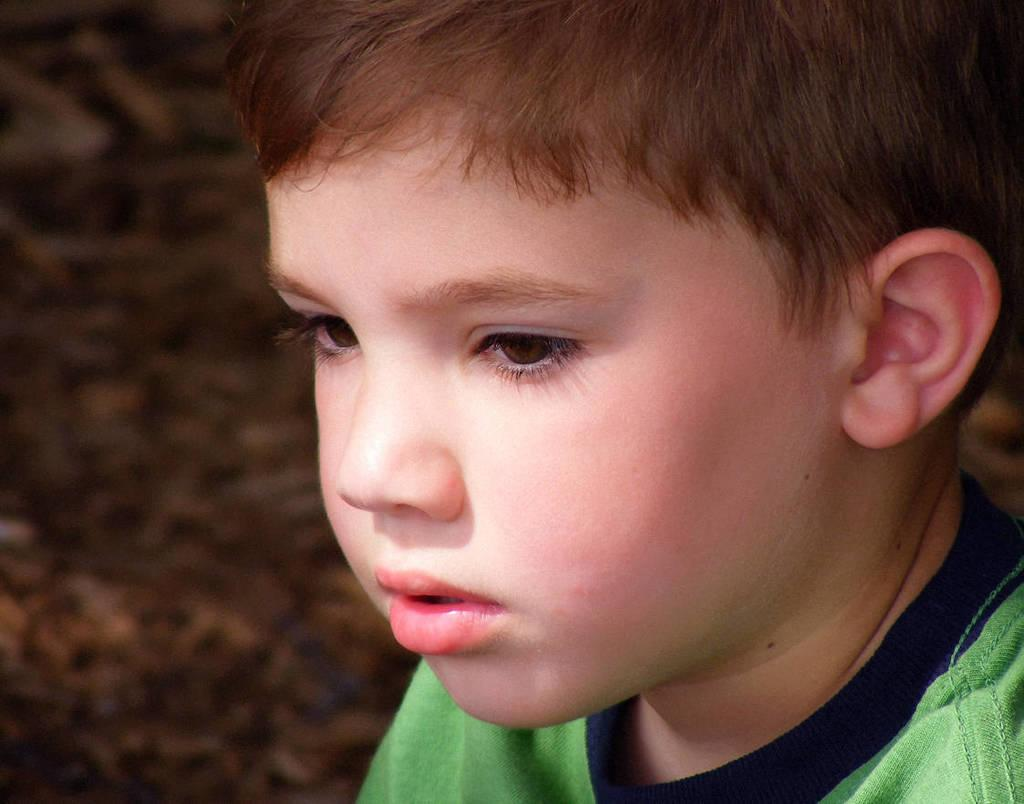What is the main subject of the image? There is a boy in the image. What type of cream can be seen on the boy's face in the image? There is no cream visible on the boy's face in the image. What kind of bun is the boy holding in the image? There is no bun present in the image. 